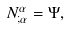Convert formula to latex. <formula><loc_0><loc_0><loc_500><loc_500>N ^ { \alpha } _ { ; \alpha } = \Psi ,</formula> 